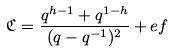<formula> <loc_0><loc_0><loc_500><loc_500>\mathfrak { C } = \frac { q ^ { h - 1 } + q ^ { 1 - h } } { ( q - q ^ { - 1 } ) ^ { 2 } } + e f</formula> 